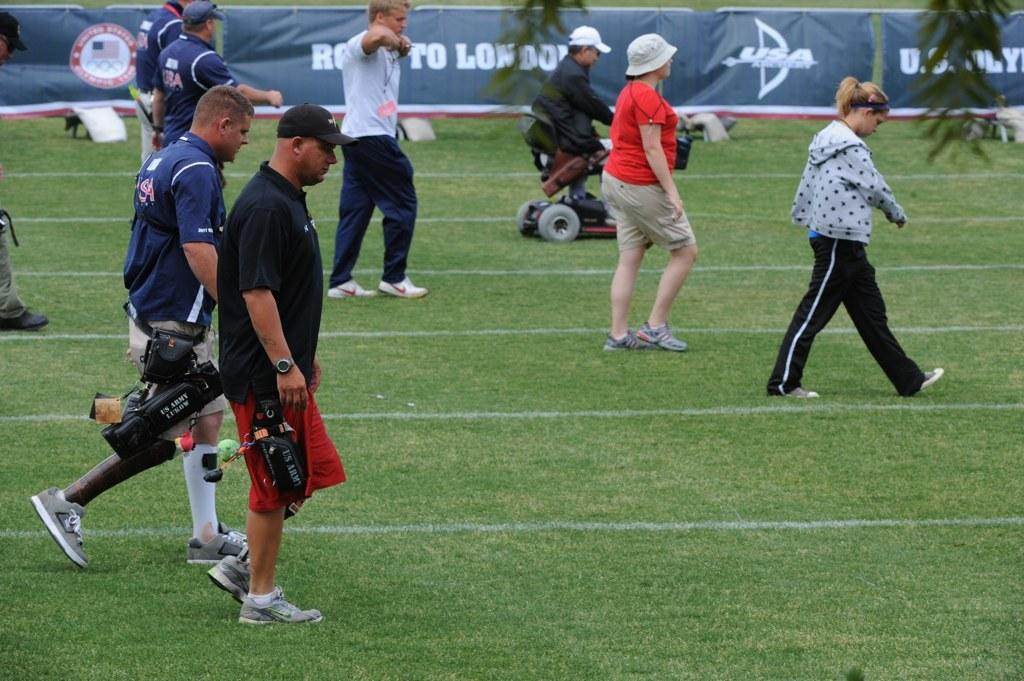<image>
Provide a brief description of the given image. Several people walk across a field in front of a banner that has "U.S." on it behind a tree limb. 